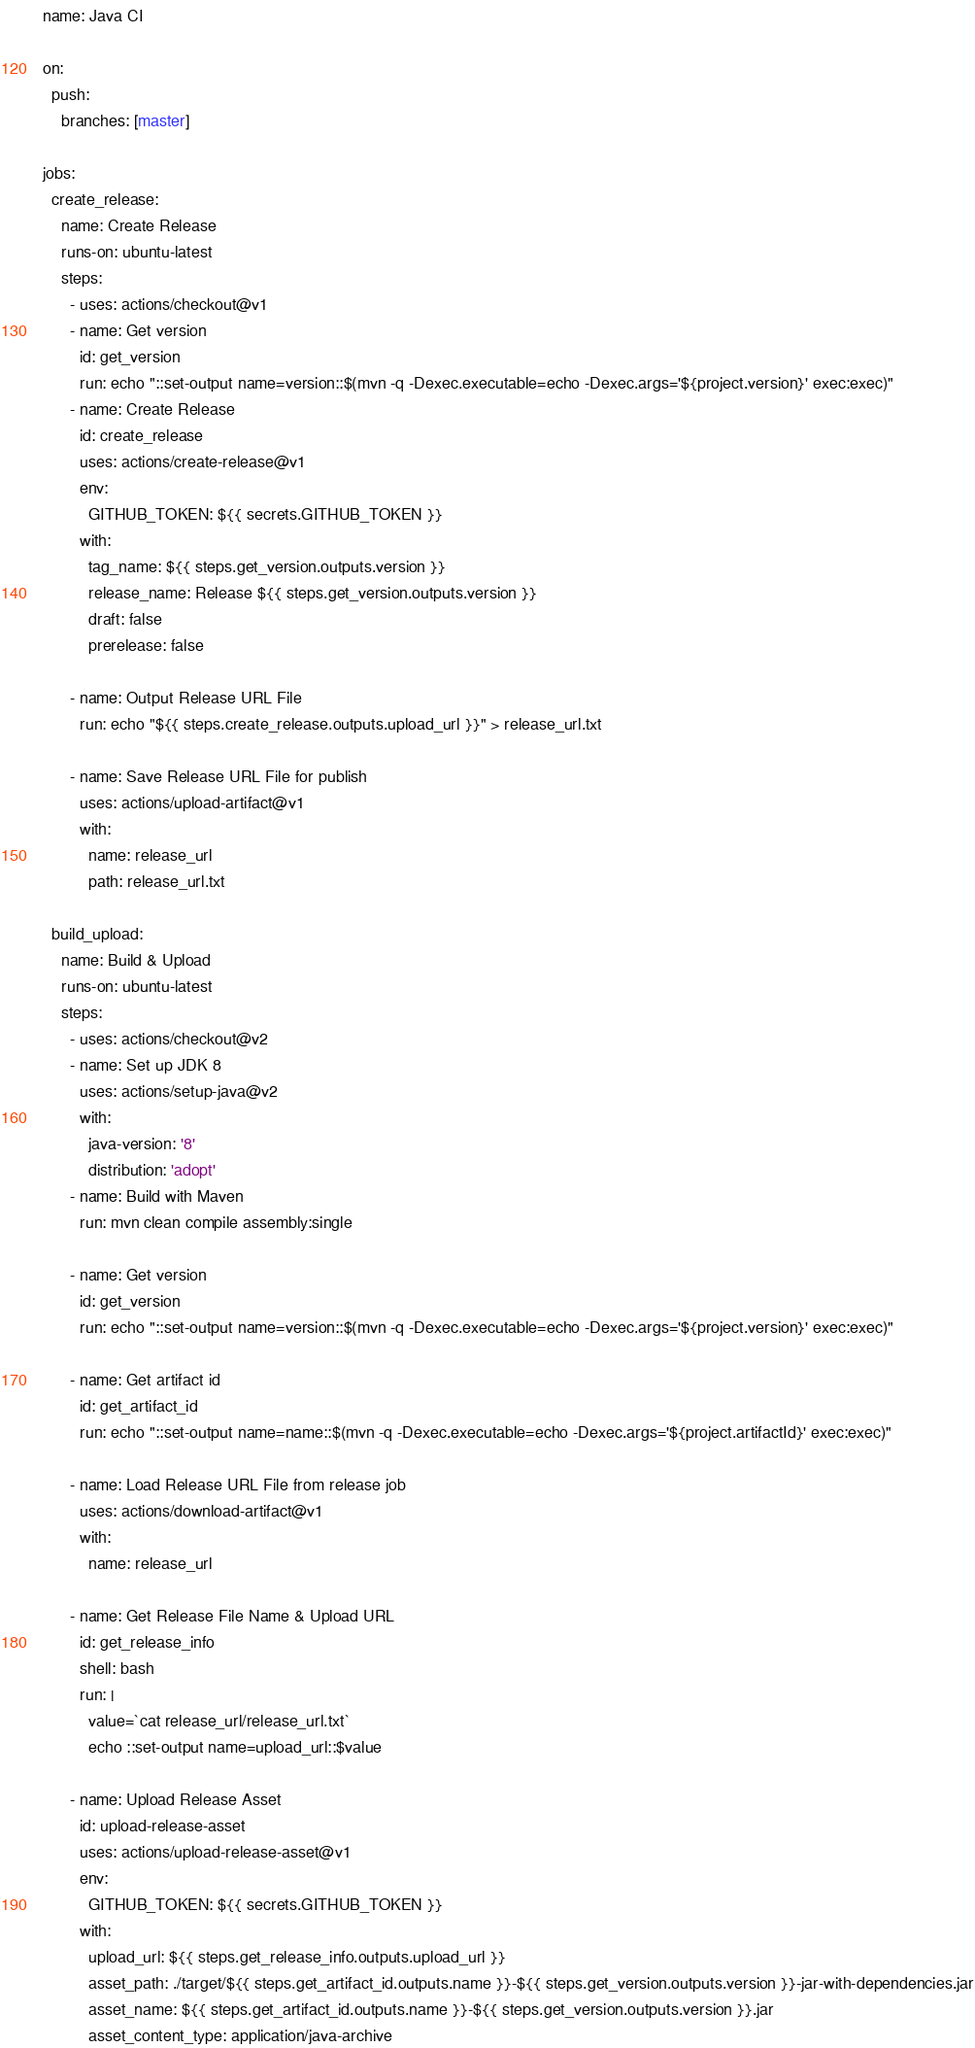Convert code to text. <code><loc_0><loc_0><loc_500><loc_500><_YAML_>name: Java CI

on:
  push:
    branches: [master]

jobs:
  create_release:
    name: Create Release
    runs-on: ubuntu-latest
    steps:
      - uses: actions/checkout@v1
      - name: Get version
        id: get_version
        run: echo "::set-output name=version::$(mvn -q -Dexec.executable=echo -Dexec.args='${project.version}' exec:exec)"
      - name: Create Release
        id: create_release
        uses: actions/create-release@v1
        env:
          GITHUB_TOKEN: ${{ secrets.GITHUB_TOKEN }}
        with:
          tag_name: ${{ steps.get_version.outputs.version }}
          release_name: Release ${{ steps.get_version.outputs.version }}
          draft: false
          prerelease: false

      - name: Output Release URL File
        run: echo "${{ steps.create_release.outputs.upload_url }}" > release_url.txt

      - name: Save Release URL File for publish
        uses: actions/upload-artifact@v1
        with:
          name: release_url
          path: release_url.txt

  build_upload:
    name: Build & Upload
    runs-on: ubuntu-latest
    steps:
      - uses: actions/checkout@v2
      - name: Set up JDK 8
        uses: actions/setup-java@v2
        with:
          java-version: '8'
          distribution: 'adopt'
      - name: Build with Maven
        run: mvn clean compile assembly:single

      - name: Get version
        id: get_version
        run: echo "::set-output name=version::$(mvn -q -Dexec.executable=echo -Dexec.args='${project.version}' exec:exec)"

      - name: Get artifact id
        id: get_artifact_id
        run: echo "::set-output name=name::$(mvn -q -Dexec.executable=echo -Dexec.args='${project.artifactId}' exec:exec)"

      - name: Load Release URL File from release job
        uses: actions/download-artifact@v1
        with:
          name: release_url

      - name: Get Release File Name & Upload URL
        id: get_release_info
        shell: bash
        run: |
          value=`cat release_url/release_url.txt`
          echo ::set-output name=upload_url::$value

      - name: Upload Release Asset
        id: upload-release-asset
        uses: actions/upload-release-asset@v1
        env:
          GITHUB_TOKEN: ${{ secrets.GITHUB_TOKEN }}
        with:
          upload_url: ${{ steps.get_release_info.outputs.upload_url }}
          asset_path: ./target/${{ steps.get_artifact_id.outputs.name }}-${{ steps.get_version.outputs.version }}-jar-with-dependencies.jar
          asset_name: ${{ steps.get_artifact_id.outputs.name }}-${{ steps.get_version.outputs.version }}.jar
          asset_content_type: application/java-archive</code> 